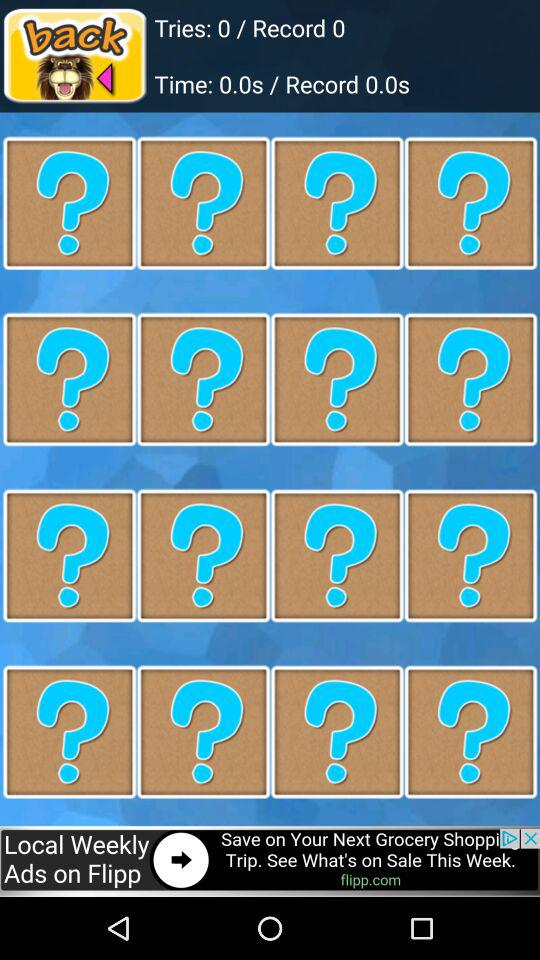What is the record time? The record time is 0 seconds. 